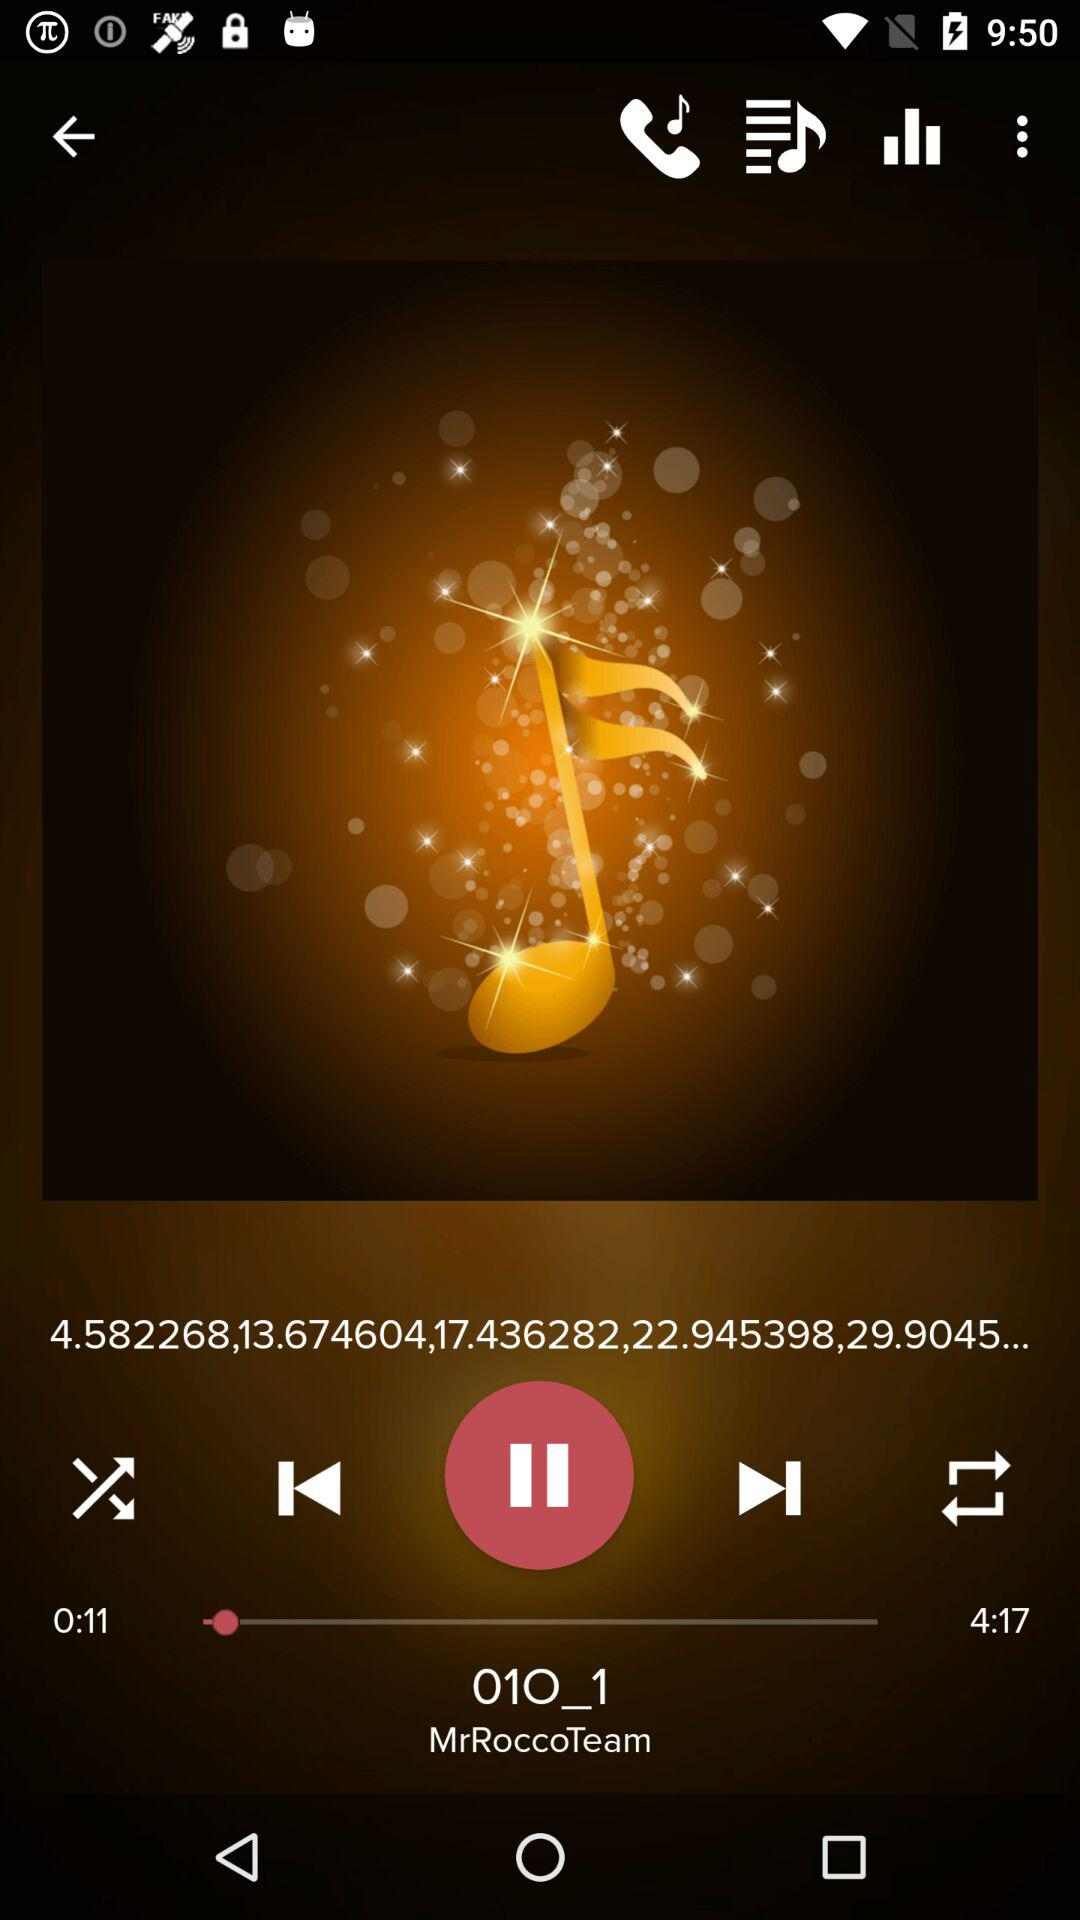What is the elapsed time of the audio? The elapsed time of the audio is 11 seconds. 